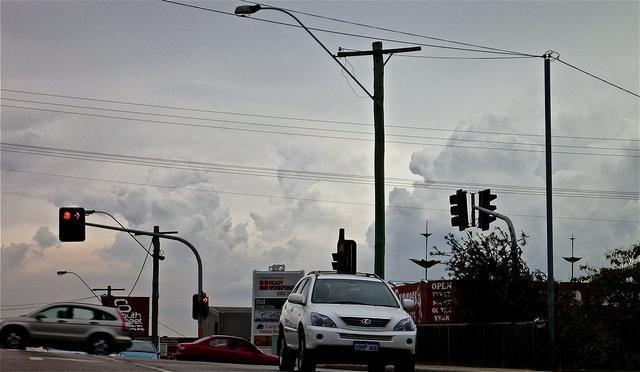How many vehicles are in the picture?
Give a very brief answer. 3. How many lamp posts are in the picture?
Give a very brief answer. 1. How many windows are on the front of the vehicle?
Give a very brief answer. 1. How many cars are in the picture?
Give a very brief answer. 3. How many zebras are facing forward?
Give a very brief answer. 0. 